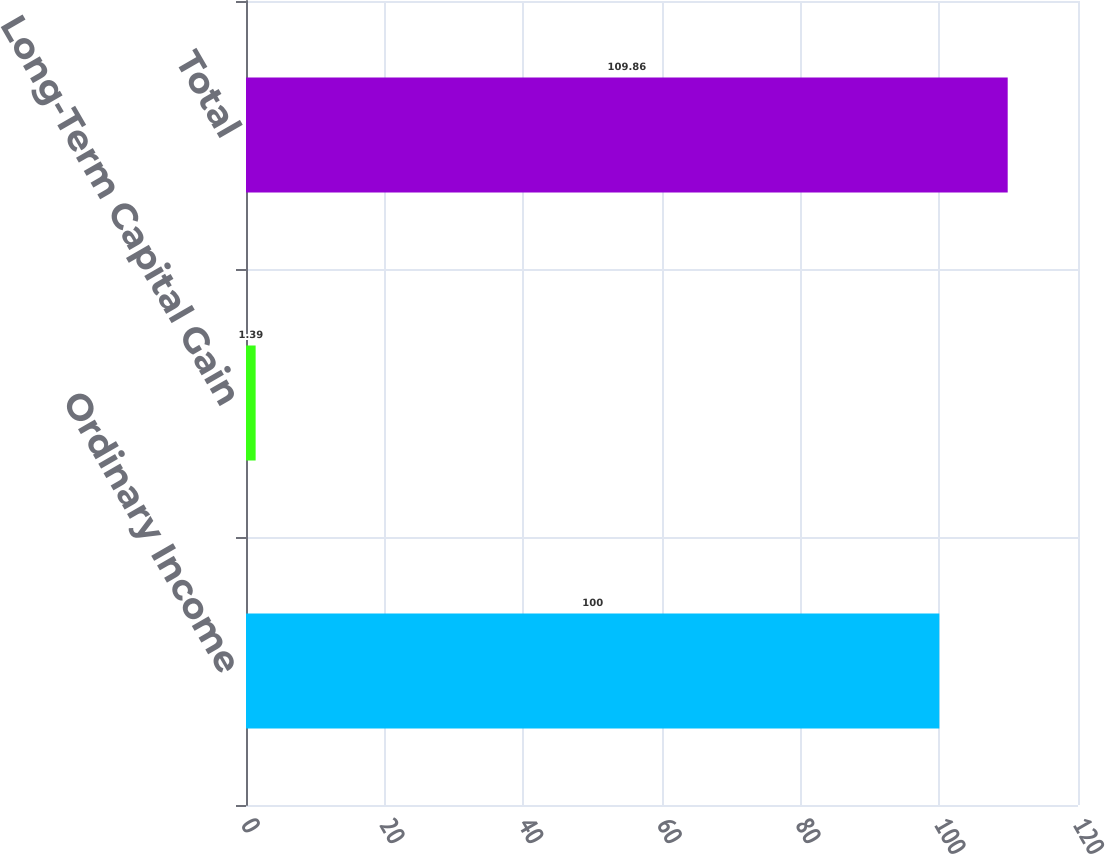Convert chart. <chart><loc_0><loc_0><loc_500><loc_500><bar_chart><fcel>Ordinary Income<fcel>Long-Term Capital Gain<fcel>Total<nl><fcel>100<fcel>1.39<fcel>109.86<nl></chart> 